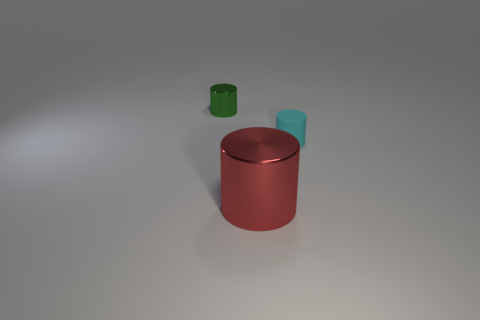Add 3 brown shiny spheres. How many objects exist? 6 Add 2 large green blocks. How many large green blocks exist? 2 Subtract 0 brown balls. How many objects are left? 3 Subtract all tiny cyan rubber things. Subtract all large cylinders. How many objects are left? 1 Add 1 green shiny things. How many green shiny things are left? 2 